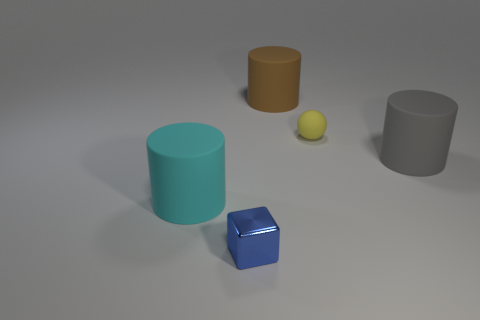Add 1 big gray matte spheres. How many objects exist? 6 Subtract all gray cylinders. How many cylinders are left? 2 Subtract all spheres. How many objects are left? 4 Subtract all green cylinders. Subtract all gray spheres. How many cylinders are left? 3 Subtract all yellow blocks. How many brown balls are left? 0 Subtract all shiny objects. Subtract all large gray cylinders. How many objects are left? 3 Add 4 small blue things. How many small blue things are left? 5 Add 5 gray shiny blocks. How many gray shiny blocks exist? 5 Subtract 0 gray cubes. How many objects are left? 5 